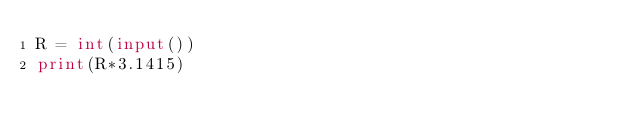Convert code to text. <code><loc_0><loc_0><loc_500><loc_500><_Python_>R = int(input())
print(R*3.1415)</code> 